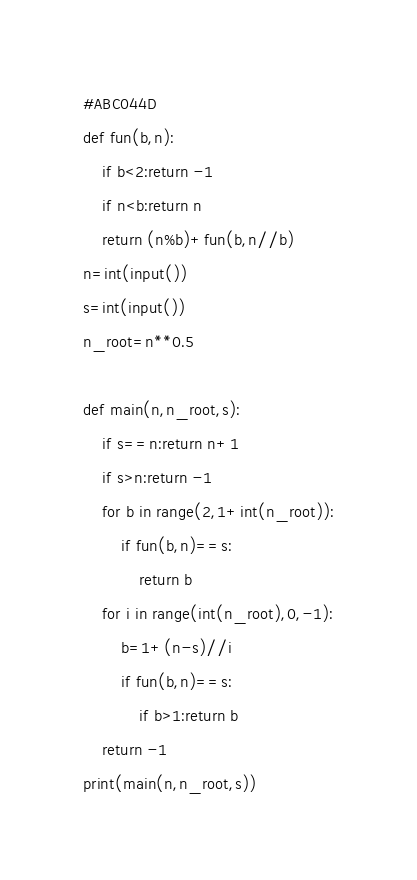Convert code to text. <code><loc_0><loc_0><loc_500><loc_500><_Python_>#ABC044D
def fun(b,n):
    if b<2:return -1
    if n<b:return n
    return (n%b)+fun(b,n//b)
n=int(input())
s=int(input())
n_root=n**0.5

def main(n,n_root,s):
    if s==n:return n+1
    if s>n:return -1
    for b in range(2,1+int(n_root)):
        if fun(b,n)==s:
            return b
    for i in range(int(n_root),0,-1):
        b=1+(n-s)//i
        if fun(b,n)==s:
            if b>1:return b
    return -1
print(main(n,n_root,s))
</code> 